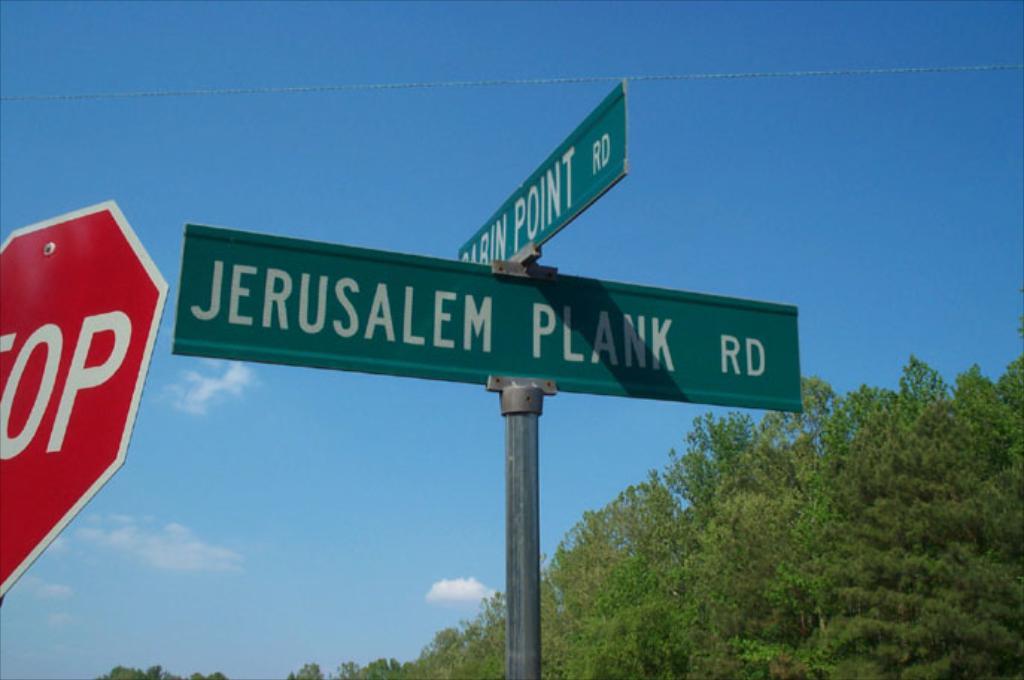What is the road name in front?
Your answer should be very brief. Jerusalem plank. 